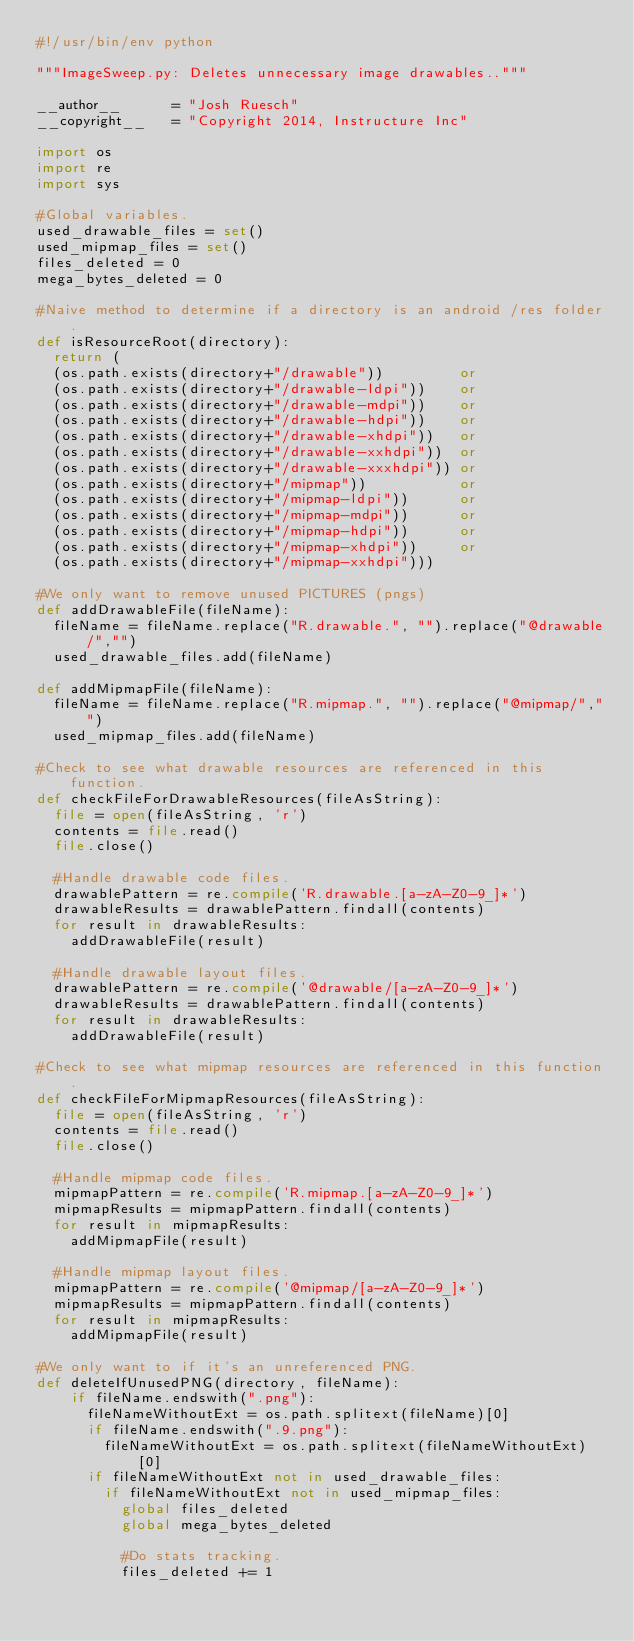<code> <loc_0><loc_0><loc_500><loc_500><_Python_>#!/usr/bin/env python

"""ImageSweep.py: Deletes unnecessary image drawables.."""

__author__      = "Josh Ruesch"
__copyright__   = "Copyright 2014, Instructure Inc"

import os
import re
import sys

#Global variables.
used_drawable_files = set()
used_mipmap_files = set()
files_deleted = 0
mega_bytes_deleted = 0

#Naive method to determine if a directory is an android /res folder.
def isResourceRoot(directory):
  return (
  (os.path.exists(directory+"/drawable"))         or
  (os.path.exists(directory+"/drawable-ldpi"))    or
  (os.path.exists(directory+"/drawable-mdpi"))    or
  (os.path.exists(directory+"/drawable-hdpi"))    or
  (os.path.exists(directory+"/drawable-xhdpi"))   or
  (os.path.exists(directory+"/drawable-xxhdpi"))  or
  (os.path.exists(directory+"/drawable-xxxhdpi")) or
  (os.path.exists(directory+"/mipmap"))           or
  (os.path.exists(directory+"/mipmap-ldpi"))      or
  (os.path.exists(directory+"/mipmap-mdpi"))      or
  (os.path.exists(directory+"/mipmap-hdpi"))      or
  (os.path.exists(directory+"/mipmap-xhdpi"))     or
  (os.path.exists(directory+"/mipmap-xxhdpi")))

#We only want to remove unused PICTURES (pngs)
def addDrawableFile(fileName):
  fileName = fileName.replace("R.drawable.", "").replace("@drawable/","")
  used_drawable_files.add(fileName)

def addMipmapFile(fileName):
  fileName = fileName.replace("R.mipmap.", "").replace("@mipmap/","")
  used_mipmap_files.add(fileName)

#Check to see what drawable resources are referenced in this function.
def checkFileForDrawableResources(fileAsString):
  file = open(fileAsString, 'r')
  contents = file.read()
  file.close()

  #Handle drawable code files.
  drawablePattern = re.compile('R.drawable.[a-zA-Z0-9_]*')
  drawableResults = drawablePattern.findall(contents)
  for result in drawableResults:
    addDrawableFile(result)

  #Handle drawable layout files.
  drawablePattern = re.compile('@drawable/[a-zA-Z0-9_]*')
  drawableResults = drawablePattern.findall(contents)
  for result in drawableResults:
    addDrawableFile(result)

#Check to see what mipmap resources are referenced in this function.
def checkFileForMipmapResources(fileAsString):
  file = open(fileAsString, 'r')
  contents = file.read()
  file.close()

  #Handle mipmap code files.
  mipmapPattern = re.compile('R.mipmap.[a-zA-Z0-9_]*')
  mipmapResults = mipmapPattern.findall(contents)
  for result in mipmapResults:
    addMipmapFile(result)

  #Handle mipmap layout files.
  mipmapPattern = re.compile('@mipmap/[a-zA-Z0-9_]*')
  mipmapResults = mipmapPattern.findall(contents)
  for result in mipmapResults:
    addMipmapFile(result)

#We only want to if it's an unreferenced PNG.
def deleteIfUnusedPNG(directory, fileName):
    if fileName.endswith(".png"):
      fileNameWithoutExt = os.path.splitext(fileName)[0]
      if fileName.endswith(".9.png"):
        fileNameWithoutExt = os.path.splitext(fileNameWithoutExt)[0]
      if fileNameWithoutExt not in used_drawable_files:
        if fileNameWithoutExt not in used_mipmap_files:
          global files_deleted
          global mega_bytes_deleted

          #Do stats tracking.
          files_deleted += 1</code> 